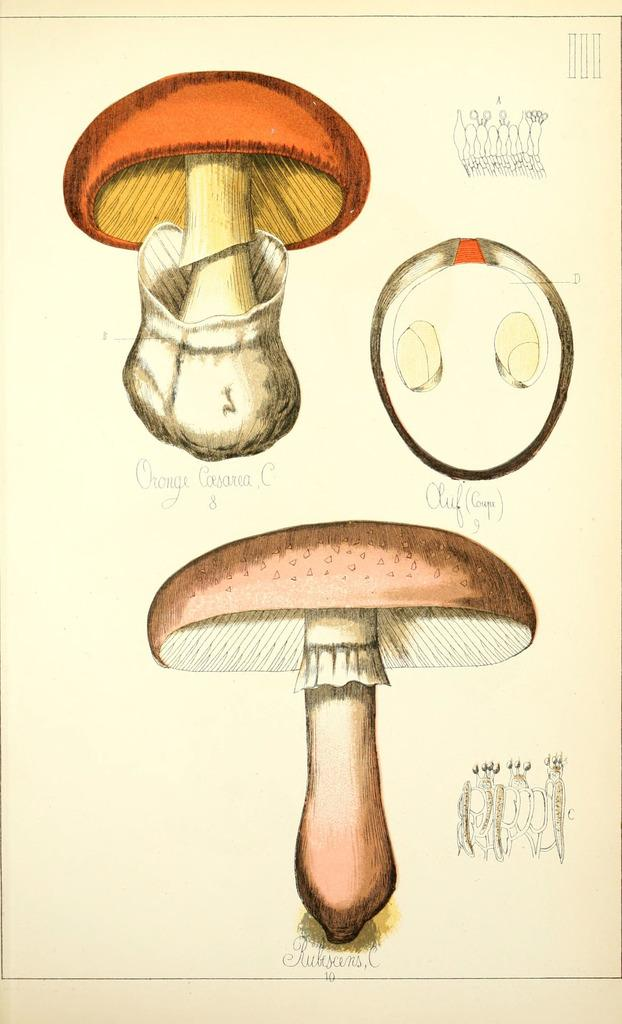How many mushrooms are present in the image? There are three mushrooms in the image. What other type of vegetable can be seen in the image? There is a group of radish in the image. Is there any text present in the image? Yes, there is text in the image. What is the background color of the image? The background color is light cream. Based on the lighting and shadows, can you determine the time of day the image was taken? The image was likely taken during the day, as there is sufficient light and no visible shadows that would suggest nighttime. What type of silk is being used to make the sister's carriage in the image? There is no silk, sister, or carriage present in the image. 